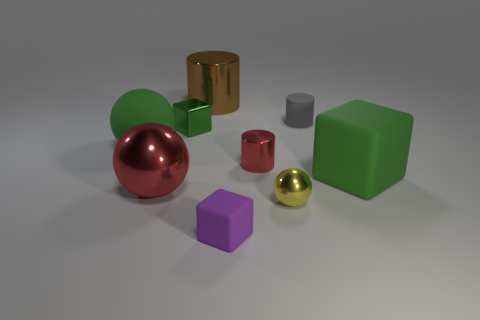Are there any tiny metallic cylinders of the same color as the small metallic cube?
Ensure brevity in your answer.  No. What color is the metallic sphere that is the same size as the purple cube?
Offer a terse response. Yellow. There is a big matte thing right of the tiny metal cylinder; what number of small rubber objects are in front of it?
Keep it short and to the point. 1. What number of objects are cubes that are to the right of the large brown cylinder or tiny cylinders?
Your answer should be very brief. 4. What number of balls are made of the same material as the tiny purple object?
Make the answer very short. 1. There is a tiny metallic object that is the same color as the large block; what shape is it?
Provide a short and direct response. Cube. Is the number of large blocks that are behind the tiny green object the same as the number of large gray matte cylinders?
Provide a succinct answer. Yes. How big is the green block on the left side of the tiny gray cylinder?
Give a very brief answer. Small. What number of large objects are green things or cyan rubber spheres?
Your answer should be compact. 2. There is a tiny metallic thing that is the same shape as the large red thing; what color is it?
Offer a very short reply. Yellow. 